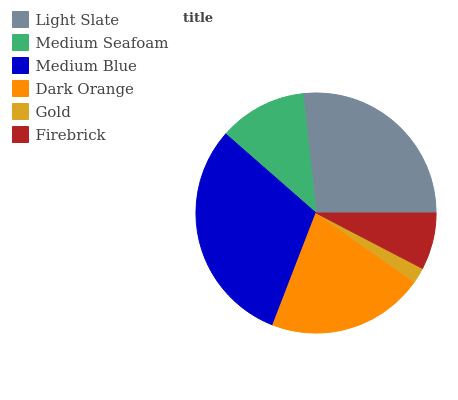Is Gold the minimum?
Answer yes or no. Yes. Is Medium Blue the maximum?
Answer yes or no. Yes. Is Medium Seafoam the minimum?
Answer yes or no. No. Is Medium Seafoam the maximum?
Answer yes or no. No. Is Light Slate greater than Medium Seafoam?
Answer yes or no. Yes. Is Medium Seafoam less than Light Slate?
Answer yes or no. Yes. Is Medium Seafoam greater than Light Slate?
Answer yes or no. No. Is Light Slate less than Medium Seafoam?
Answer yes or no. No. Is Dark Orange the high median?
Answer yes or no. Yes. Is Medium Seafoam the low median?
Answer yes or no. Yes. Is Light Slate the high median?
Answer yes or no. No. Is Gold the low median?
Answer yes or no. No. 